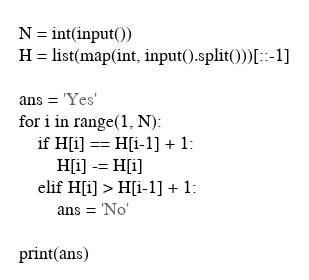Convert code to text. <code><loc_0><loc_0><loc_500><loc_500><_Python_>N = int(input())
H = list(map(int, input().split()))[::-1]

ans = 'Yes'
for i in range(1, N):
    if H[i] == H[i-1] + 1:
        H[i] -= H[i]
    elif H[i] > H[i-1] + 1:
        ans = 'No'

print(ans)
</code> 